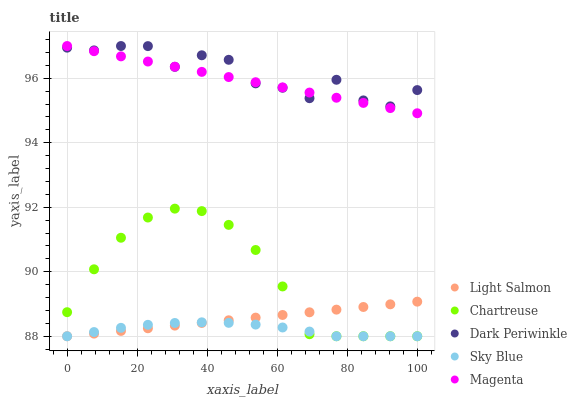Does Sky Blue have the minimum area under the curve?
Answer yes or no. Yes. Does Dark Periwinkle have the maximum area under the curve?
Answer yes or no. Yes. Does Light Salmon have the minimum area under the curve?
Answer yes or no. No. Does Light Salmon have the maximum area under the curve?
Answer yes or no. No. Is Light Salmon the smoothest?
Answer yes or no. Yes. Is Dark Periwinkle the roughest?
Answer yes or no. Yes. Is Chartreuse the smoothest?
Answer yes or no. No. Is Chartreuse the roughest?
Answer yes or no. No. Does Sky Blue have the lowest value?
Answer yes or no. Yes. Does Magenta have the lowest value?
Answer yes or no. No. Does Dark Periwinkle have the highest value?
Answer yes or no. Yes. Does Light Salmon have the highest value?
Answer yes or no. No. Is Sky Blue less than Magenta?
Answer yes or no. Yes. Is Dark Periwinkle greater than Chartreuse?
Answer yes or no. Yes. Does Light Salmon intersect Chartreuse?
Answer yes or no. Yes. Is Light Salmon less than Chartreuse?
Answer yes or no. No. Is Light Salmon greater than Chartreuse?
Answer yes or no. No. Does Sky Blue intersect Magenta?
Answer yes or no. No. 